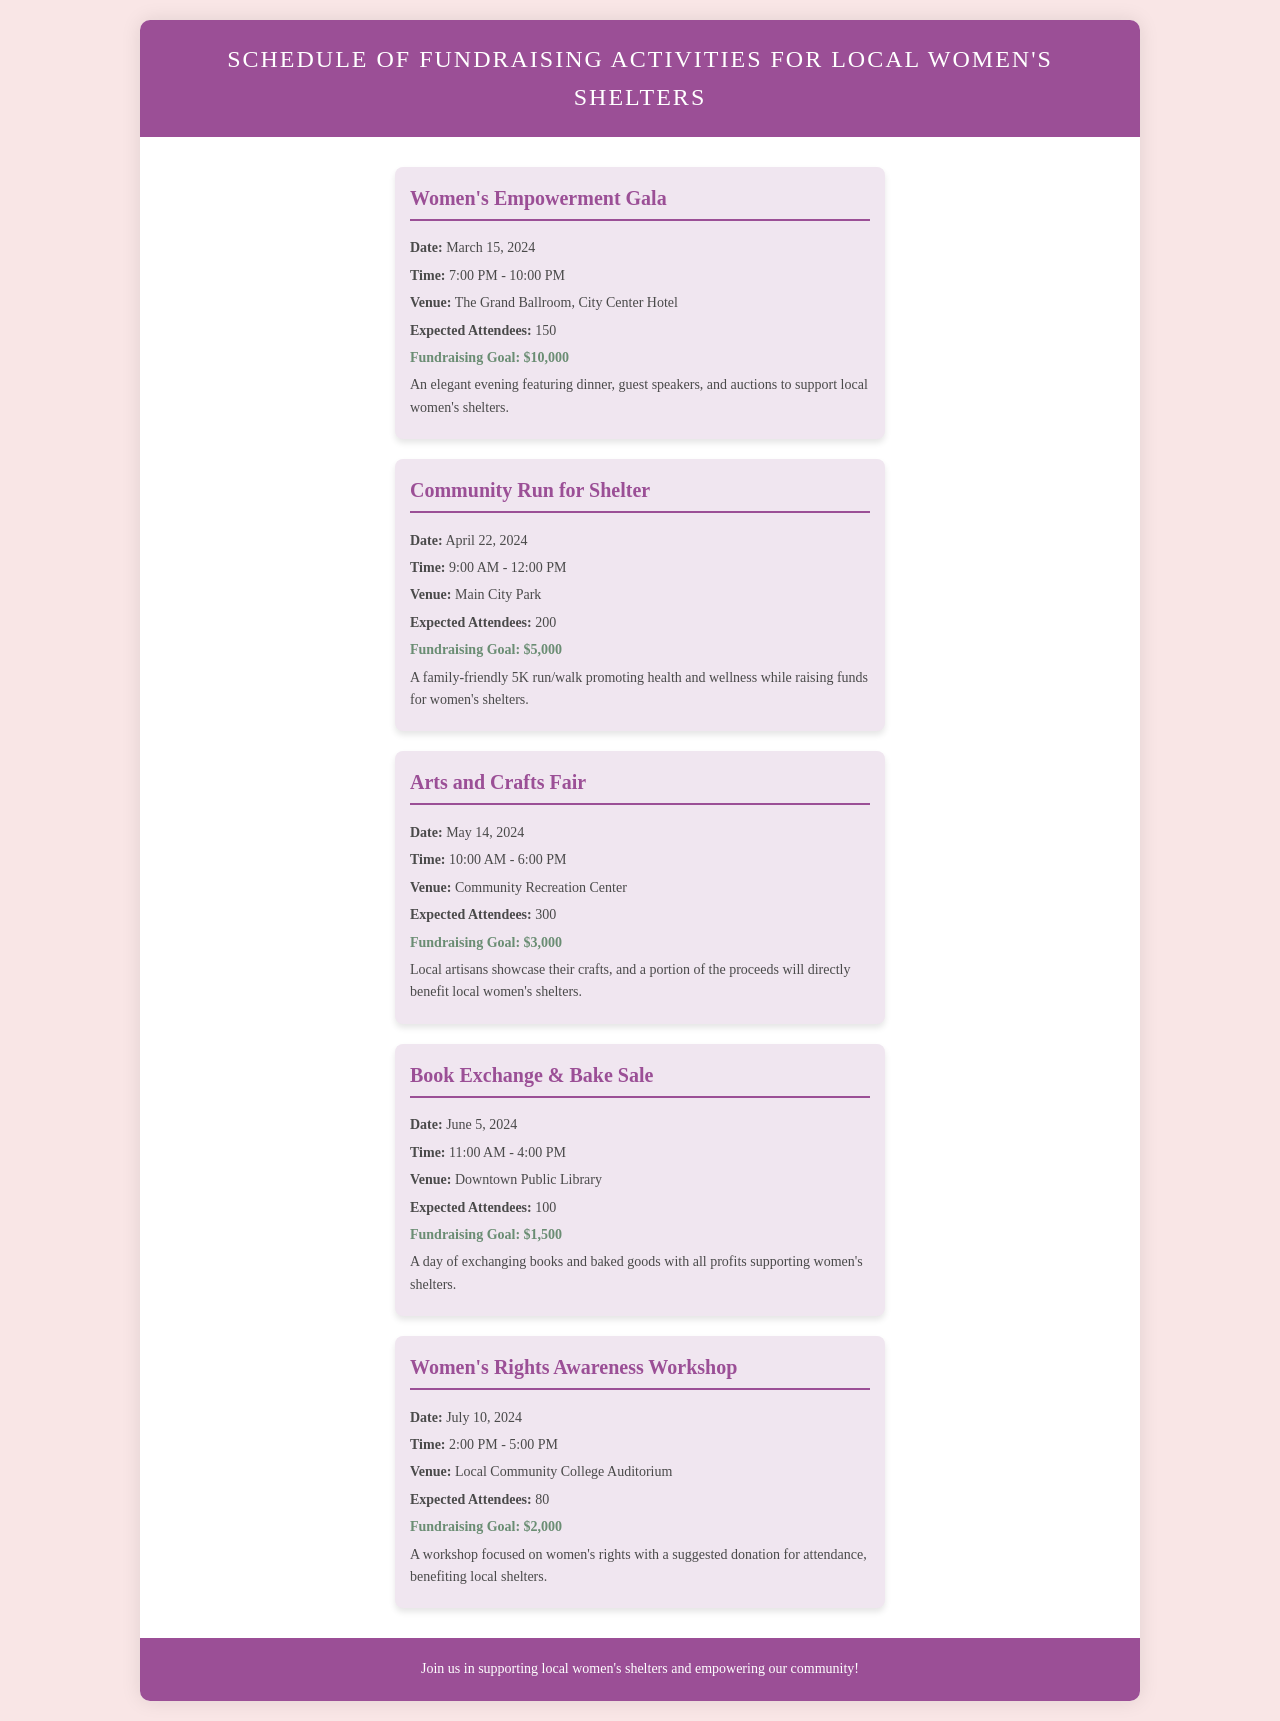What is the date of the Women's Empowerment Gala? The date for the Women's Empowerment Gala is specified in the document.
Answer: March 15, 2024 What is the fundraising goal for the Community Run for Shelter? The fundraising goal for the Community Run for Shelter can be found in the event details.
Answer: $5,000 How many expected attendees are there for the Arts and Crafts Fair? The expected number of attendees for the Arts and Crafts Fair is mentioned in the schedule.
Answer: 300 What time does the Book Exchange & Bake Sale start? The start time for the Book Exchange & Bake Sale is listed in the event details.
Answer: 11:00 AM Which venue hosts the Women's Rights Awareness Workshop? The venue for the Women's Rights Awareness Workshop is provided in the event information.
Answer: Local Community College Auditorium How many total events are listed in the document? The total number of events can be counted from the items in the schedule.
Answer: 5 Which event has the lowest fundraising goal? The event with the lowest fundraising goal is the one with the least amount mentioned among the events.
Answer: Book Exchange & Bake Sale What type of event is the Community Run for Shelter? The nature or type of the Community Run for Shelter is described in the document.
Answer: 5K run/walk 